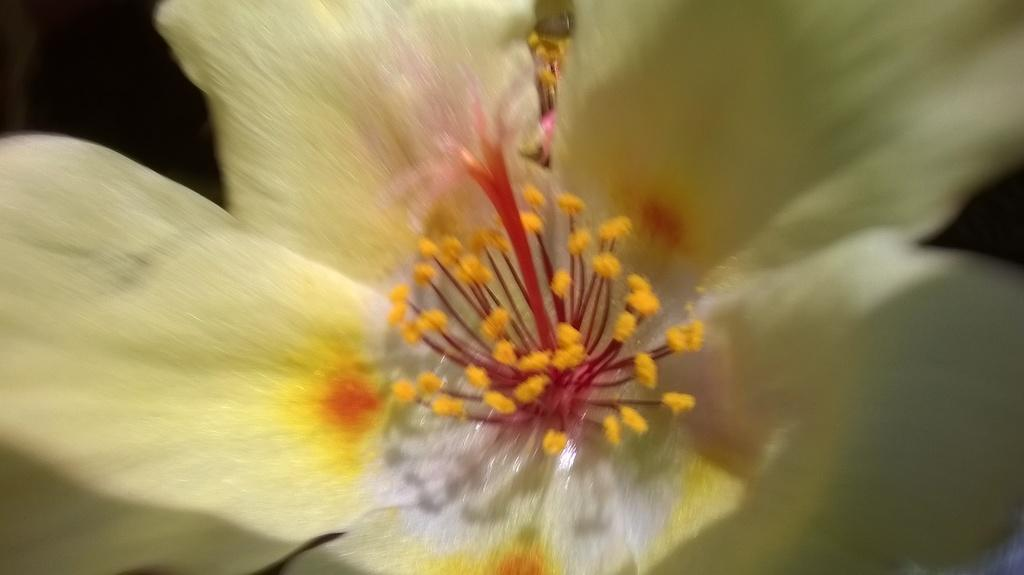What is the main subject of the image? There is a flower in the image. What type of reading material can be seen near the flower in the image? There is no reading material present in the image; it only features a flower. What type of weather condition is depicted in the image? The image does not depict any weather conditions, as it only features a flower. 